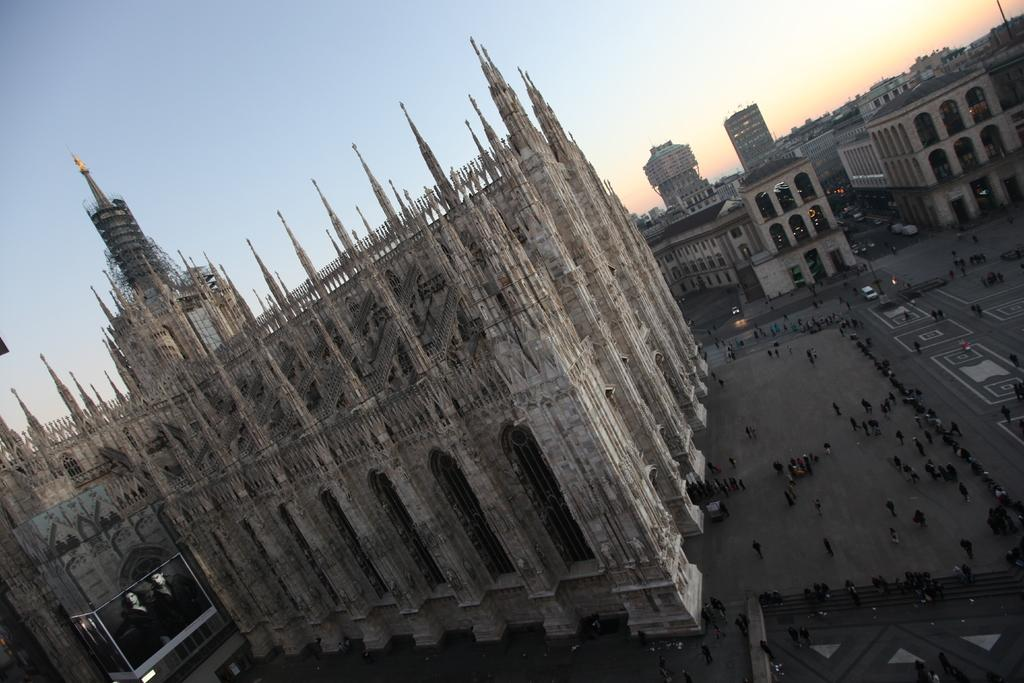What type of structure is the main subject of the image? There is a castle in the image. What else can be seen on the ground in the image? There are people on the road in the image. What architectural features are visible on the castle? There are windows and arches visible in the image. What other structures are present in the image? There are buildings in the image. What is visible at the top of the image? The sky is visible at the top of the image. What type of stamp can be seen on the floor in the image? There is no stamp present in the image, and the floor is not mentioned in the provided facts. 